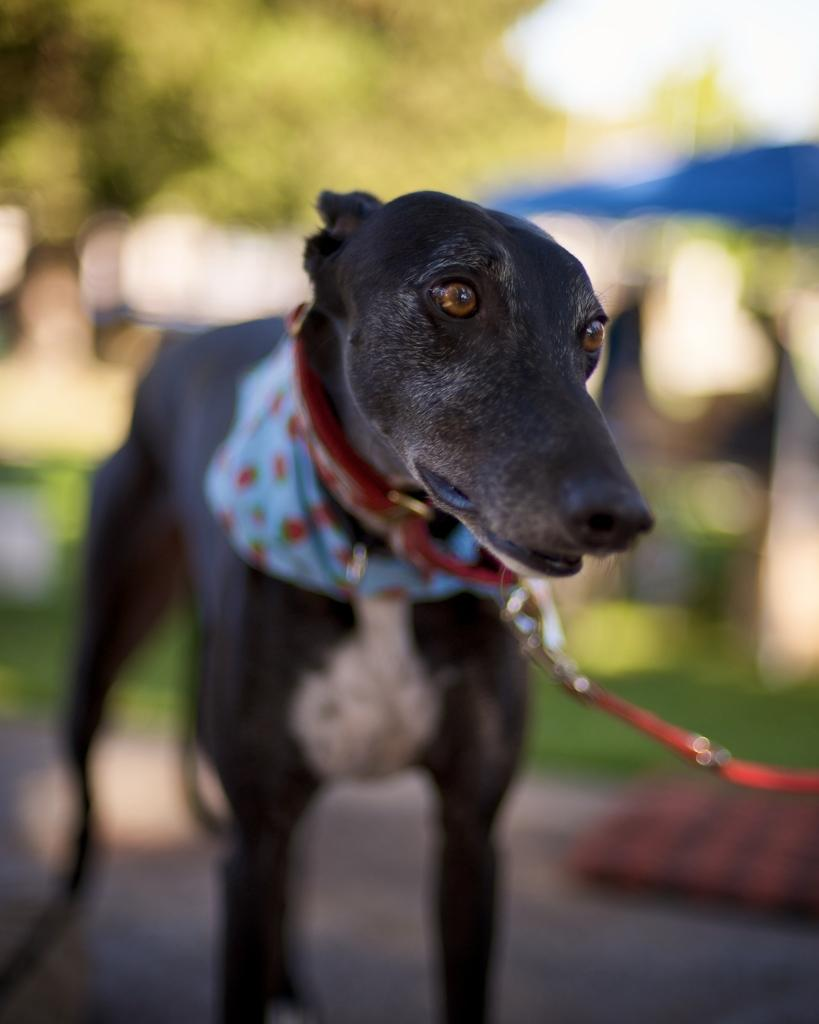What is the main subject in the center of the image? There is a dog in the center of the image. How is the dog secured in the image? The dog is tied with a belt. What is the color of the dog in the image? The dog is black in color. How many giants are holding the dog in the image? There are no giants present in the image, and the dog is not being held by any giants. What type of grip does the dog have on the belt in the image? The dog is not shown gripping the belt in the image; it is simply tied with it. 